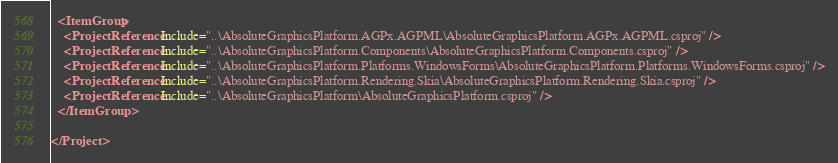Convert code to text. <code><loc_0><loc_0><loc_500><loc_500><_XML_>
  <ItemGroup>
    <ProjectReference Include="..\AbsoluteGraphicsPlatform.AGPx.AGPML\AbsoluteGraphicsPlatform.AGPx.AGPML.csproj" />
    <ProjectReference Include="..\AbsoluteGraphicsPlatform.Components\AbsoluteGraphicsPlatform.Components.csproj" />
    <ProjectReference Include="..\AbsoluteGraphicsPlatform.Platforms.WindowsForms\AbsoluteGraphicsPlatform.Platforms.WindowsForms.csproj" />
    <ProjectReference Include="..\AbsoluteGraphicsPlatform.Rendering.Skia\AbsoluteGraphicsPlatform.Rendering.Skia.csproj" />
    <ProjectReference Include="..\AbsoluteGraphicsPlatform\AbsoluteGraphicsPlatform.csproj" />
  </ItemGroup>

</Project>
</code> 